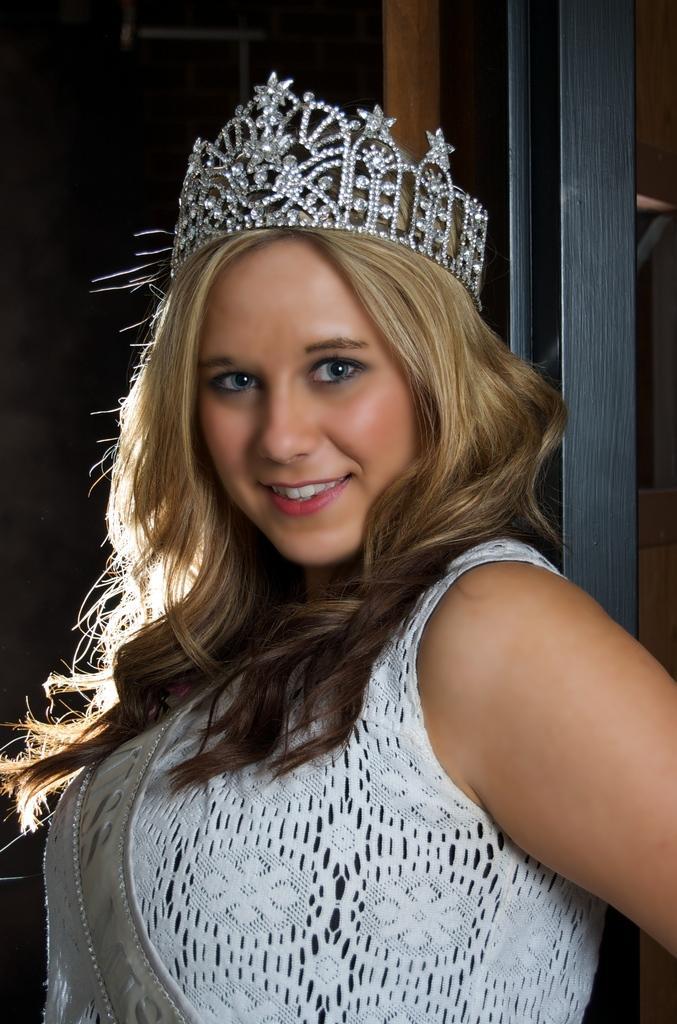Can you describe this image briefly? In the center of the image we can see a lady standing. She is wearing a crown. In the background there is a door. 